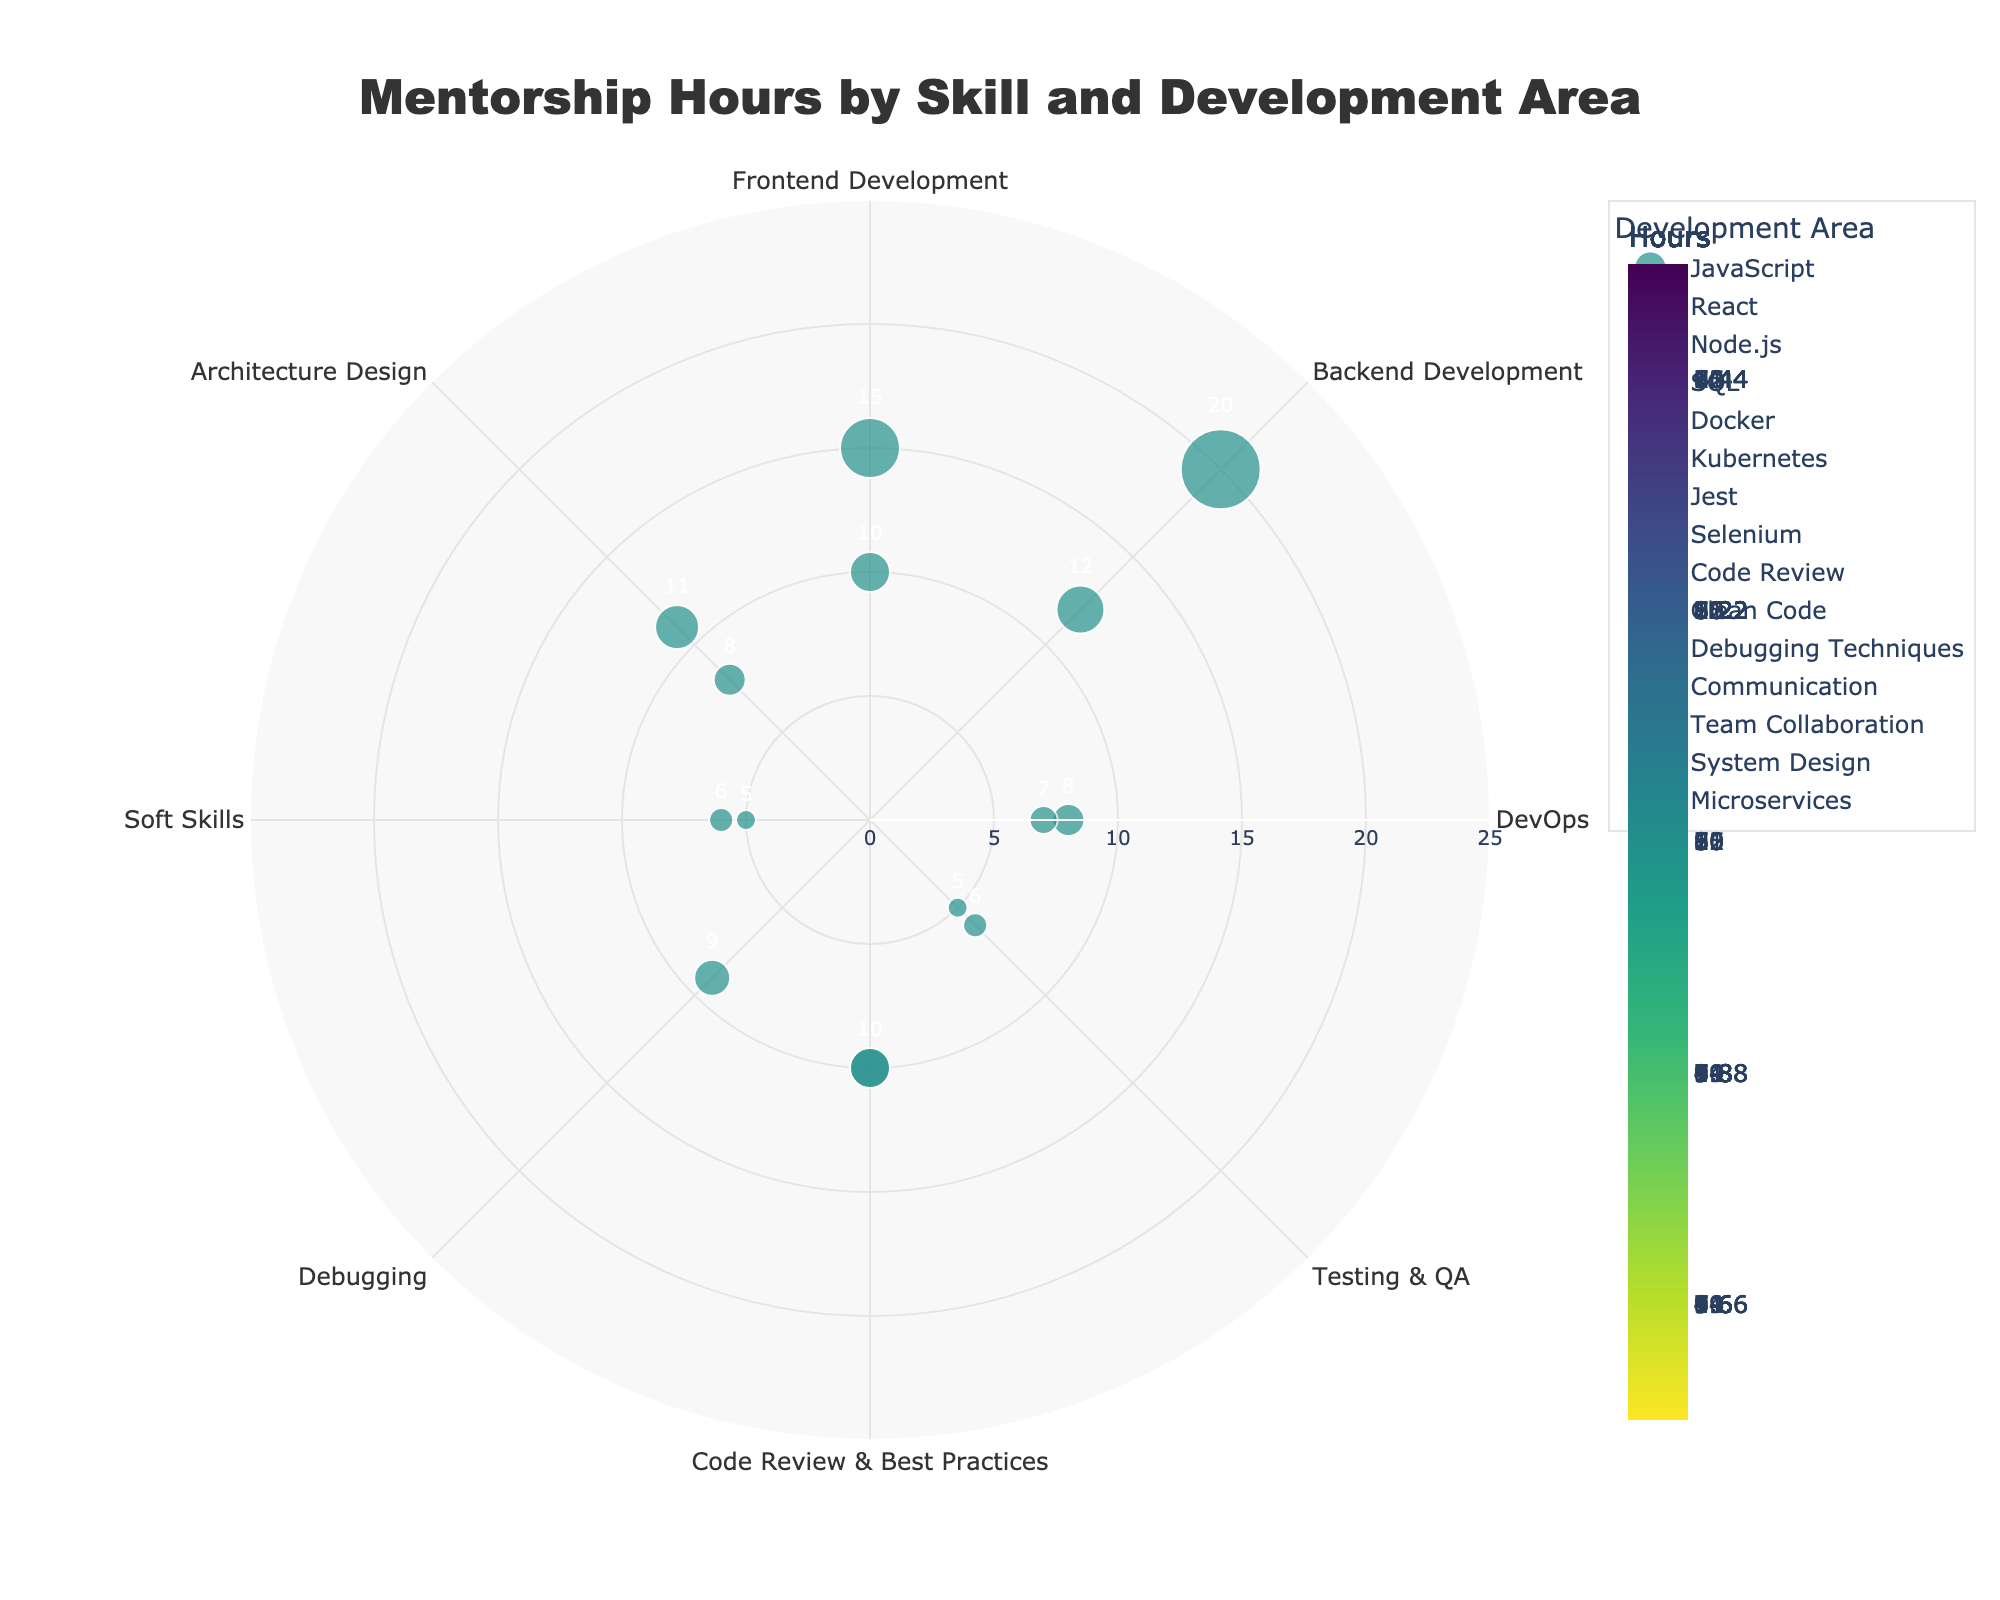How many mentorship hours were spent on JavaScript? The graph shows the mentorship hours for JavaScript as indicated next to the data point labeled "JavaScript" in the figure.
Answer: 15 What is the development area with the highest number of mentorship hours, and what skill does it correspond to? The graph shows that Backend Development has the highest mentorship hours with Node.js at 20 hours.
Answer: Backend Development, Node.js Which skill in the DevOps area received the least mentorship hours? In the graph, under DevOps, Kubernetes has fewer mentorship hours than Docker at 7 hours.
Answer: Kubernetes What is the sum of mentorship hours spent on Frontend Development skills? The figure indicates 15 hours for JavaScript and 10 hours for React. Adding these gives 15 + 10 = 25 hours.
Answer: 25 Compare the mentorship hours in Testing & QA with those in Soft Skills. Which area received more attention and by how much? The figure shows a total of 11 hours for Testing & QA (5 for Jest + 6 for Selenium) and 11 hours for Soft Skills (5 for Communication + 6 for Team Collaboration). Since both areas have the same number of hours, there is no difference.
Answer: Same, 0 What skill in Code Review & Best Practices received equal mentorship hours to a skill in Frontend Development? According to the figure, both Code Review (Code Review & Best Practices) and React (Frontend Development) received 10 mentorship hours.
Answer: Code Review and React What is the average number of mentorship hours spent on skills in the Architecture Design area? The figure shows 11 hours for System Design and 8 hours for Microservices. The average is (11 + 8) / 2 = 9.5 hours.
Answer: 9.5 Which skill in the figure has the smallest marker size and how many hours were spent on it? The figure indicates that Jest has the smallest marker size which corresponds to 5 mentorship hours.
Answer: Jest, 5 Considering only Backend Development, how many more hours were spent on Node.js compared to SQL? The figure specifies 20 hours for Node.js and 12 hours for SQL. The difference is 20 - 12 = 8 hours.
Answer: 8 How does the skill Debugging Techniques compare to Frontend Development skills in terms of mentorship hours? The figure shows 9 hours for Debugging Techniques. For Frontend Development, JavaScript has 15 hours and React has 10 hours, both higher than 9.
Answer: Less 